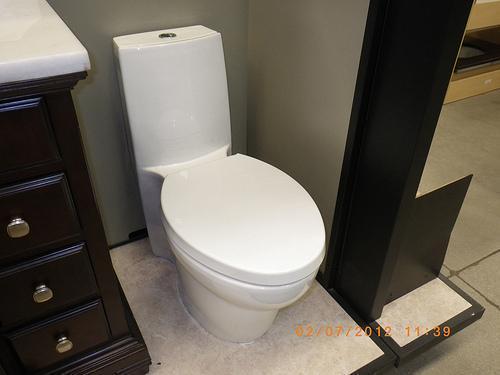How many toilets are there?
Give a very brief answer. 1. 